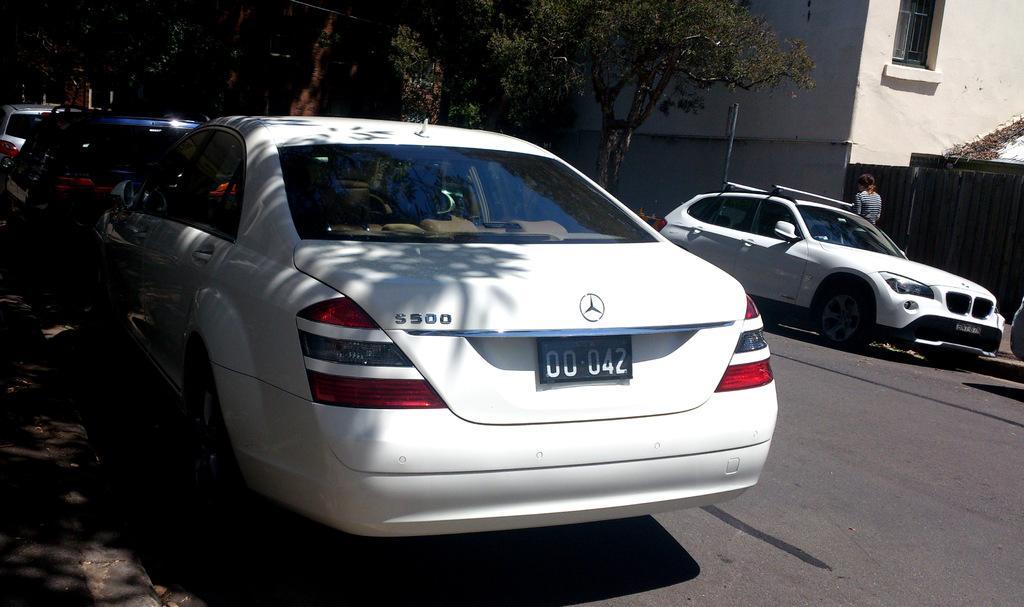Describe this image in one or two sentences. In this image, we can see vehicles on the road and on the right, there is a person standing. In the background, we can see trees and there is a building. 